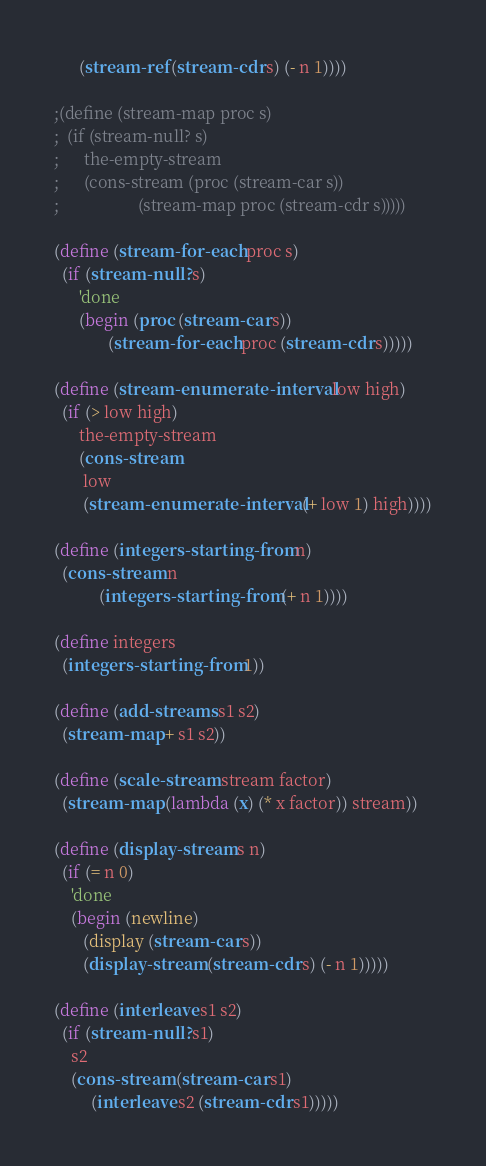Convert code to text. <code><loc_0><loc_0><loc_500><loc_500><_Scheme_>      (stream-ref (stream-cdr s) (- n 1))))

;(define (stream-map proc s)
;  (if (stream-null? s)
;      the-empty-stream
;      (cons-stream (proc (stream-car s))
;                   (stream-map proc (stream-cdr s)))))

(define (stream-for-each proc s)
  (if (stream-null? s)
      'done
      (begin (proc (stream-car s))
             (stream-for-each proc (stream-cdr s)))))

(define (stream-enumerate-interval low high)
  (if (> low high)
      the-empty-stream
      (cons-stream
       low
       (stream-enumerate-interval (+ low 1) high))))

(define (integers-starting-from n)
  (cons-stream n
	       (integers-starting-from (+ n 1))))

(define integers
  (integers-starting-from 1))

(define (add-streams s1 s2)
  (stream-map + s1 s2))

(define (scale-stream stream factor)
  (stream-map (lambda (x) (* x factor)) stream))

(define (display-stream s n)
  (if (= n 0)
    'done
    (begin (newline)
	   (display (stream-car s))
	   (display-stream (stream-cdr s) (- n 1)))))

(define (interleave s1 s2)
  (if (stream-null? s1)
    s2
    (cons-stream (stream-car s1)
		 (interleave s2 (stream-cdr s1)))))


</code> 